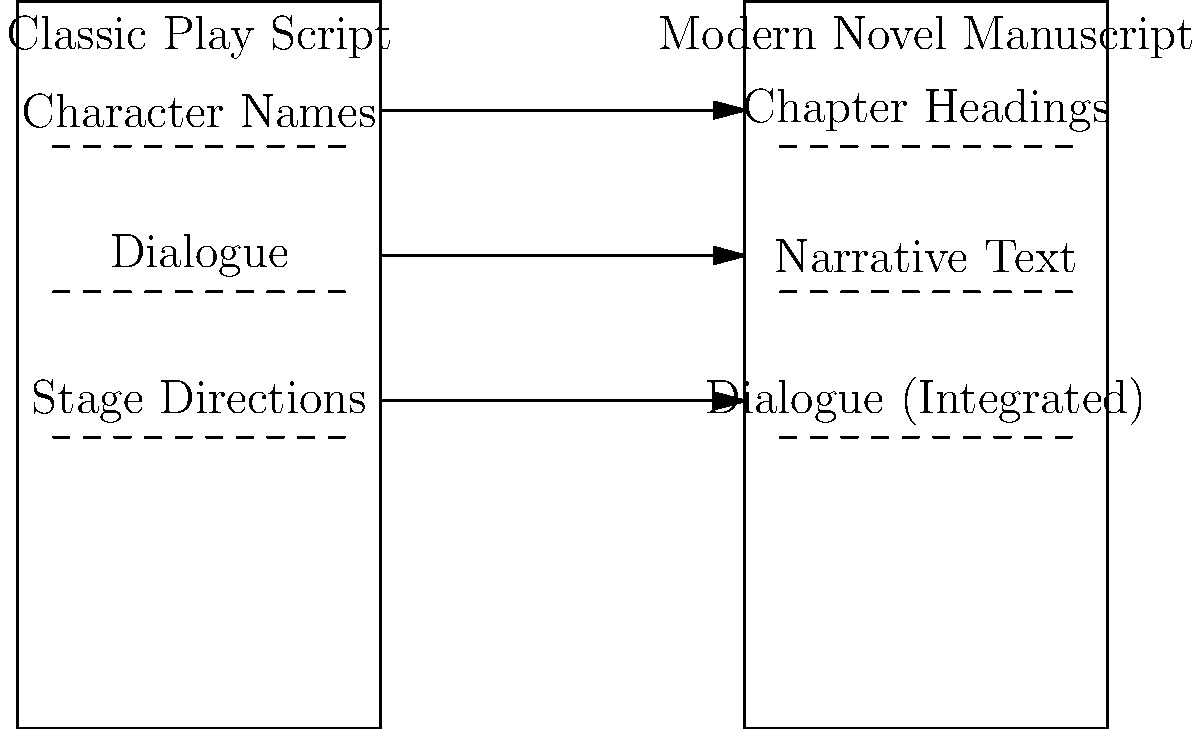As a former aspiring actress now working in book editing, how would you describe the key structural difference between a classic play script and a modern novel manuscript in terms of how dialogue is presented? To answer this question, let's analyze the structural differences between a classic play script and a modern novel manuscript:

1. Classic Play Script Structure:
   - Character names are typically listed separately.
   - Dialogue is presented as distinct lines, often preceded by the character's name.
   - Stage directions are usually separate from the dialogue, often in parentheses or italics.

2. Modern Novel Manuscript Structure:
   - Chapter headings divide the text into sections.
   - Narrative text forms the bulk of the content.
   - Dialogue is integrated within the narrative, often using quotation marks.

3. Key Difference in Dialogue Presentation:
   - In a play script, dialogue is the primary content, presented in a structured format with character names clearly delineated.
   - In a novel manuscript, dialogue is embedded within the narrative flow, requiring additional context and description.

4. Impact on Reading and Performance:
   - Play scripts are designed for performance, with clear speaker identification and minimal narrative interruption.
   - Novel manuscripts require readers to engage with both dialogue and narrative elements simultaneously.

The key structural difference in dialogue presentation is that play scripts isolate dialogue as the main content, while novel manuscripts integrate dialogue within a broader narrative context.
Answer: Play scripts isolate dialogue; novels integrate it within narrative. 